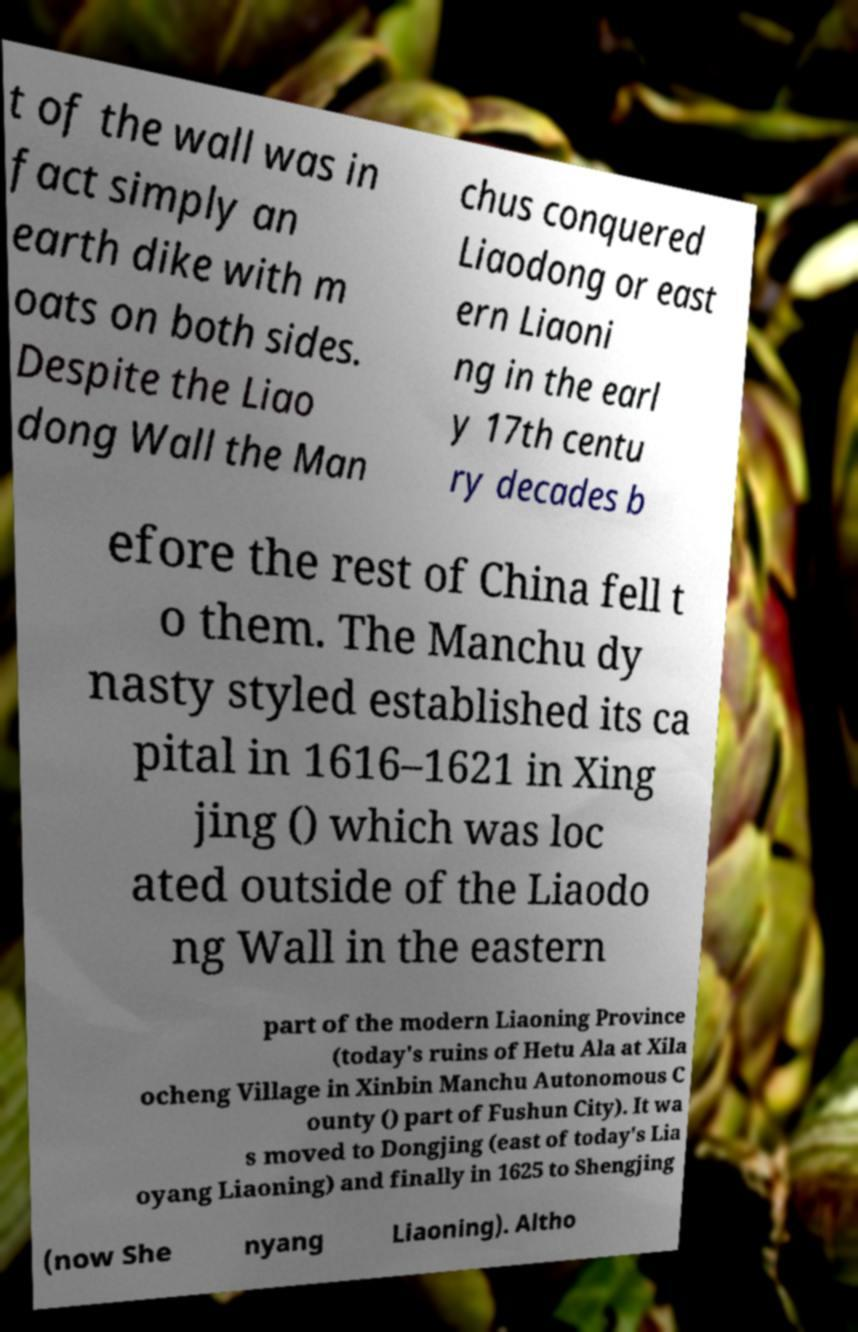Can you accurately transcribe the text from the provided image for me? t of the wall was in fact simply an earth dike with m oats on both sides. Despite the Liao dong Wall the Man chus conquered Liaodong or east ern Liaoni ng in the earl y 17th centu ry decades b efore the rest of China fell t o them. The Manchu dy nasty styled established its ca pital in 1616–1621 in Xing jing () which was loc ated outside of the Liaodo ng Wall in the eastern part of the modern Liaoning Province (today's ruins of Hetu Ala at Xila ocheng Village in Xinbin Manchu Autonomous C ounty () part of Fushun City). It wa s moved to Dongjing (east of today's Lia oyang Liaoning) and finally in 1625 to Shengjing (now She nyang Liaoning). Altho 